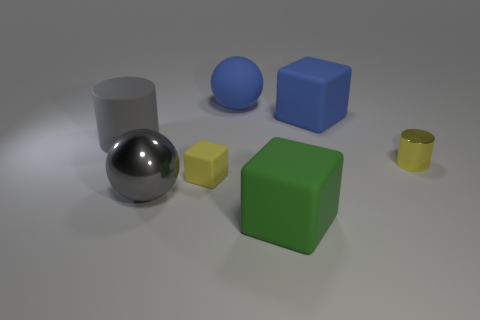There is a shiny sphere; does it have the same color as the large block right of the large green block?
Give a very brief answer. No. Are there more metal cylinders than large red things?
Your answer should be very brief. Yes. Are there any other things that are the same color as the large rubber ball?
Your answer should be very brief. Yes. How many other things are there of the same size as the rubber cylinder?
Provide a short and direct response. 4. What is the material of the large ball that is behind the metallic thing behind the shiny thing left of the yellow rubber thing?
Your answer should be very brief. Rubber. Are the small block and the blue object that is behind the big blue rubber cube made of the same material?
Give a very brief answer. Yes. Are there fewer blocks on the left side of the matte cylinder than metal spheres that are in front of the gray metal object?
Offer a very short reply. No. What number of gray objects have the same material as the big cylinder?
Ensure brevity in your answer.  0. There is a yellow thing that is on the left side of the ball that is behind the tiny yellow cylinder; is there a green block that is behind it?
Ensure brevity in your answer.  No. What number of cubes are either red things or gray objects?
Your answer should be compact. 0. 